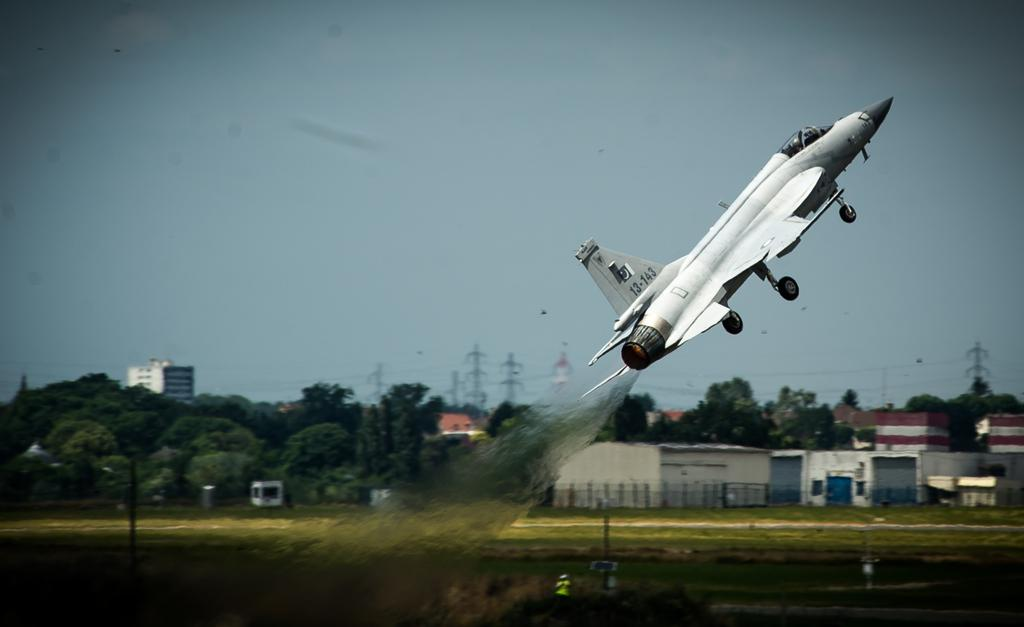<image>
Share a concise interpretation of the image provided. A fighter jet with the tail number 13143 is taking off from an air port. 